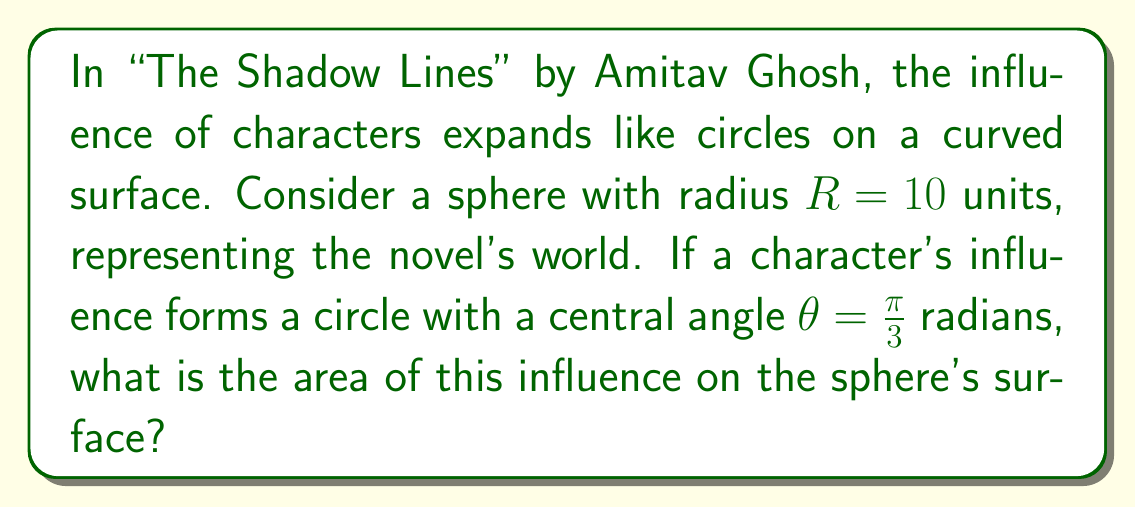What is the answer to this math problem? To solve this problem, we need to use the formula for the area of a spherical cap:

1) The area of a spherical cap is given by:
   $$A = 2\pi R h$$
   where $R$ is the radius of the sphere and $h$ is the height of the cap.

2) We need to find $h$. In a sphere, $h$ is related to the central angle $\theta$ by:
   $$h = R(1 - \cos(\frac{\theta}{2}))$$

3) Substituting the given values:
   $$h = 10(1 - \cos(\frac{\pi}{6}))$$

4) Calculate:
   $$h = 10(1 - \frac{\sqrt{3}}{2}) \approx 1.3397$$

5) Now we can calculate the area:
   $$A = 2\pi R h$$
   $$A = 2\pi(10)(1.3397)$$
   $$A \approx 84.1018$$

6) Therefore, the area of influence on the sphere's surface is approximately 84.1018 square units.

This area symbolizes the expanding influence of characters in "The Shadow Lines", spread across the curved surface of the novel's world.
Answer: $84.1018$ square units 